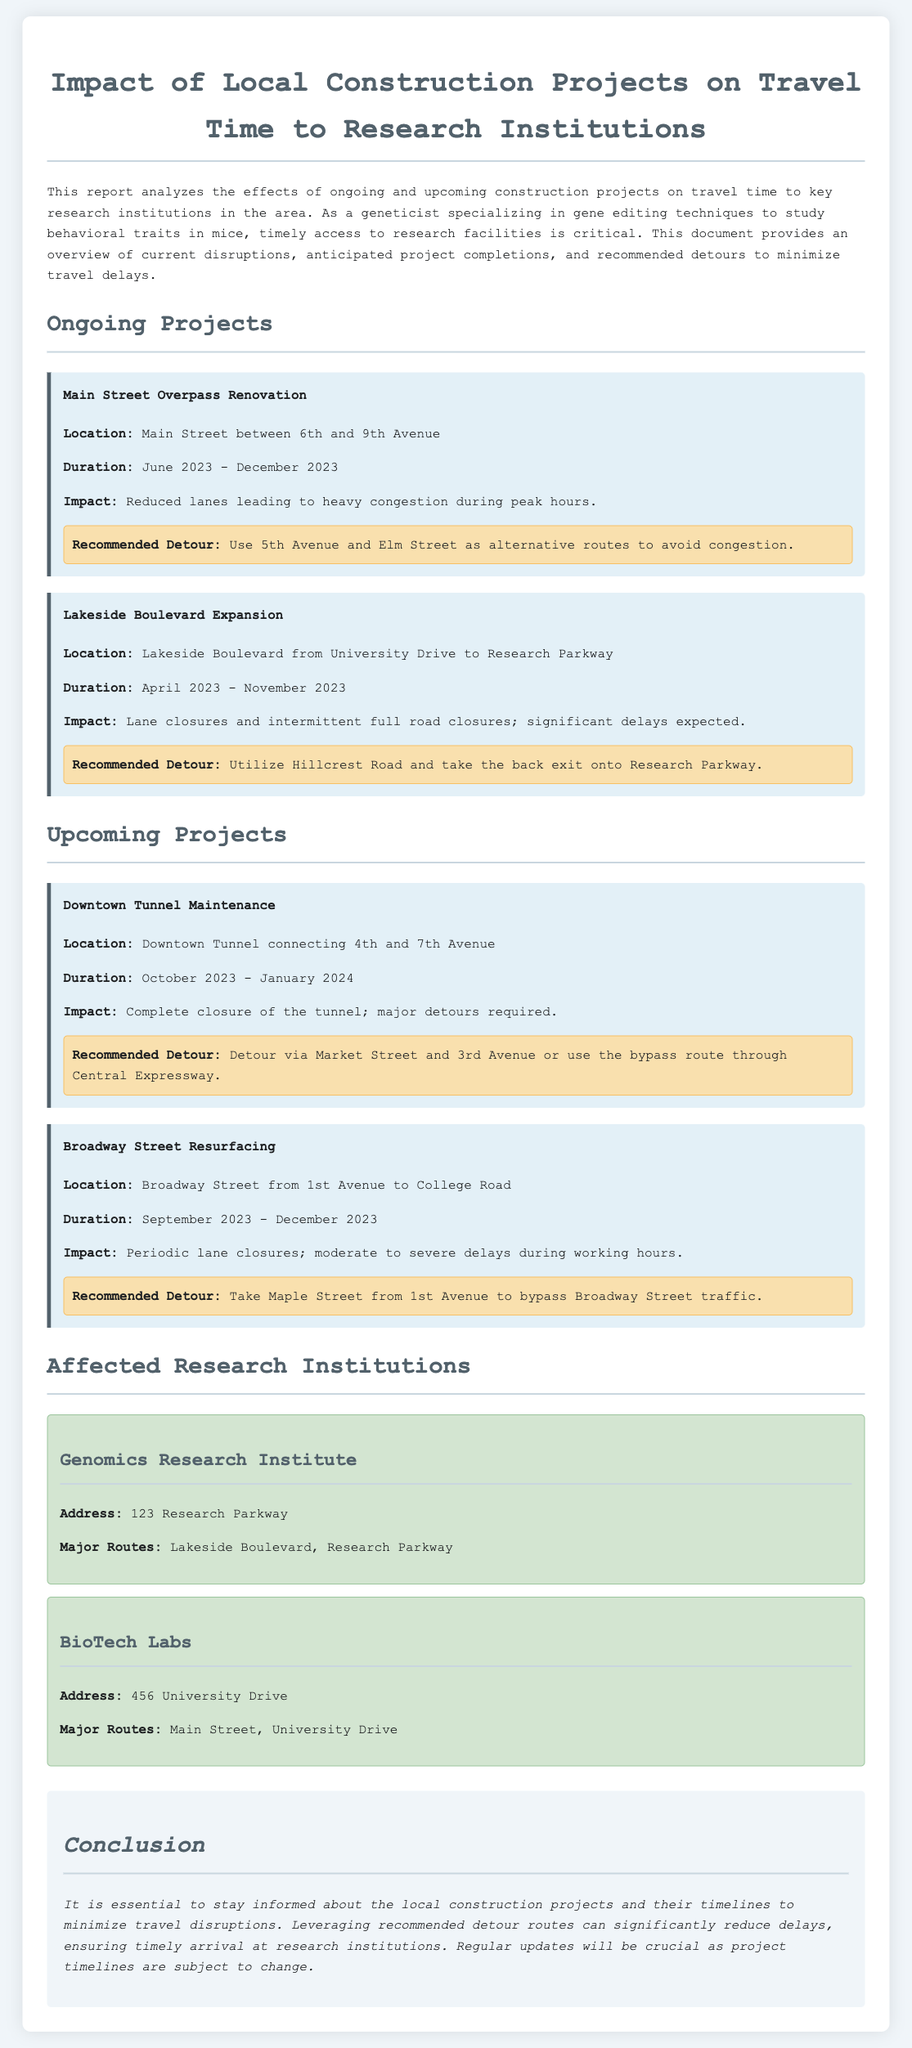What is the location of the Main Street Overpass Renovation? The location is specified as Main Street between 6th and 9th Avenue.
Answer: Main Street between 6th and 9th Avenue What is the expected duration of the Lakeside Boulevard Expansion? The duration mentioned for this project is from April 2023 to November 2023.
Answer: April 2023 - November 2023 What is the major route to the Genomics Research Institute? The document states that the major routes include Lakeside Boulevard and Research Parkway.
Answer: Lakeside Boulevard, Research Parkway How long will the Downtown Tunnel Maintenance take? The expected duration is from October 2023 to January 2024, indicating a 4-month period.
Answer: October 2023 - January 2024 What is the impact of the Broadway Street Resurfacing project? The document notes periodic lane closures and moderate to severe delays during working hours.
Answer: Periodic lane closures; moderate to severe delays What is the recommended detour for the Lakeside Boulevard Expansion? The detour suggested is to utilize Hillcrest Road and take the back exit onto Research Parkway.
Answer: Utilize Hillcrest Road and take the back exit onto Research Parkway What construction project is ongoing that affects travel during peak hours? The ongoing project that impacts travel during peak hours is the Main Street Overpass Renovation, leading to heavy congestion.
Answer: Main Street Overpass Renovation What is the purpose of this traffic report? The report aims to analyze the effects of construction projects on travel time to key research institutions.
Answer: Analyze the effects of construction projects on travel time to key research institutions 